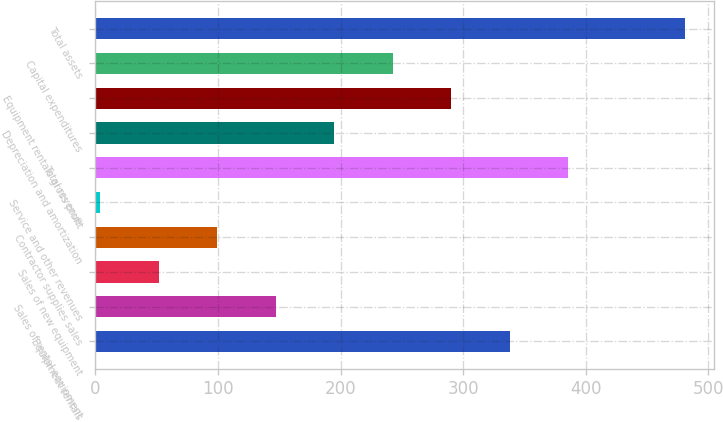Convert chart. <chart><loc_0><loc_0><loc_500><loc_500><bar_chart><fcel>Equipment rentals<fcel>Sales of rental equipment<fcel>Sales of new equipment<fcel>Contractor supplies sales<fcel>Service and other revenues<fcel>Total revenue<fcel>Depreciation and amortization<fcel>Equipment rentals gross profit<fcel>Capital expenditures<fcel>Total assets<nl><fcel>337.9<fcel>147.1<fcel>51.7<fcel>99.4<fcel>4<fcel>385.6<fcel>194.8<fcel>290.2<fcel>242.5<fcel>481<nl></chart> 